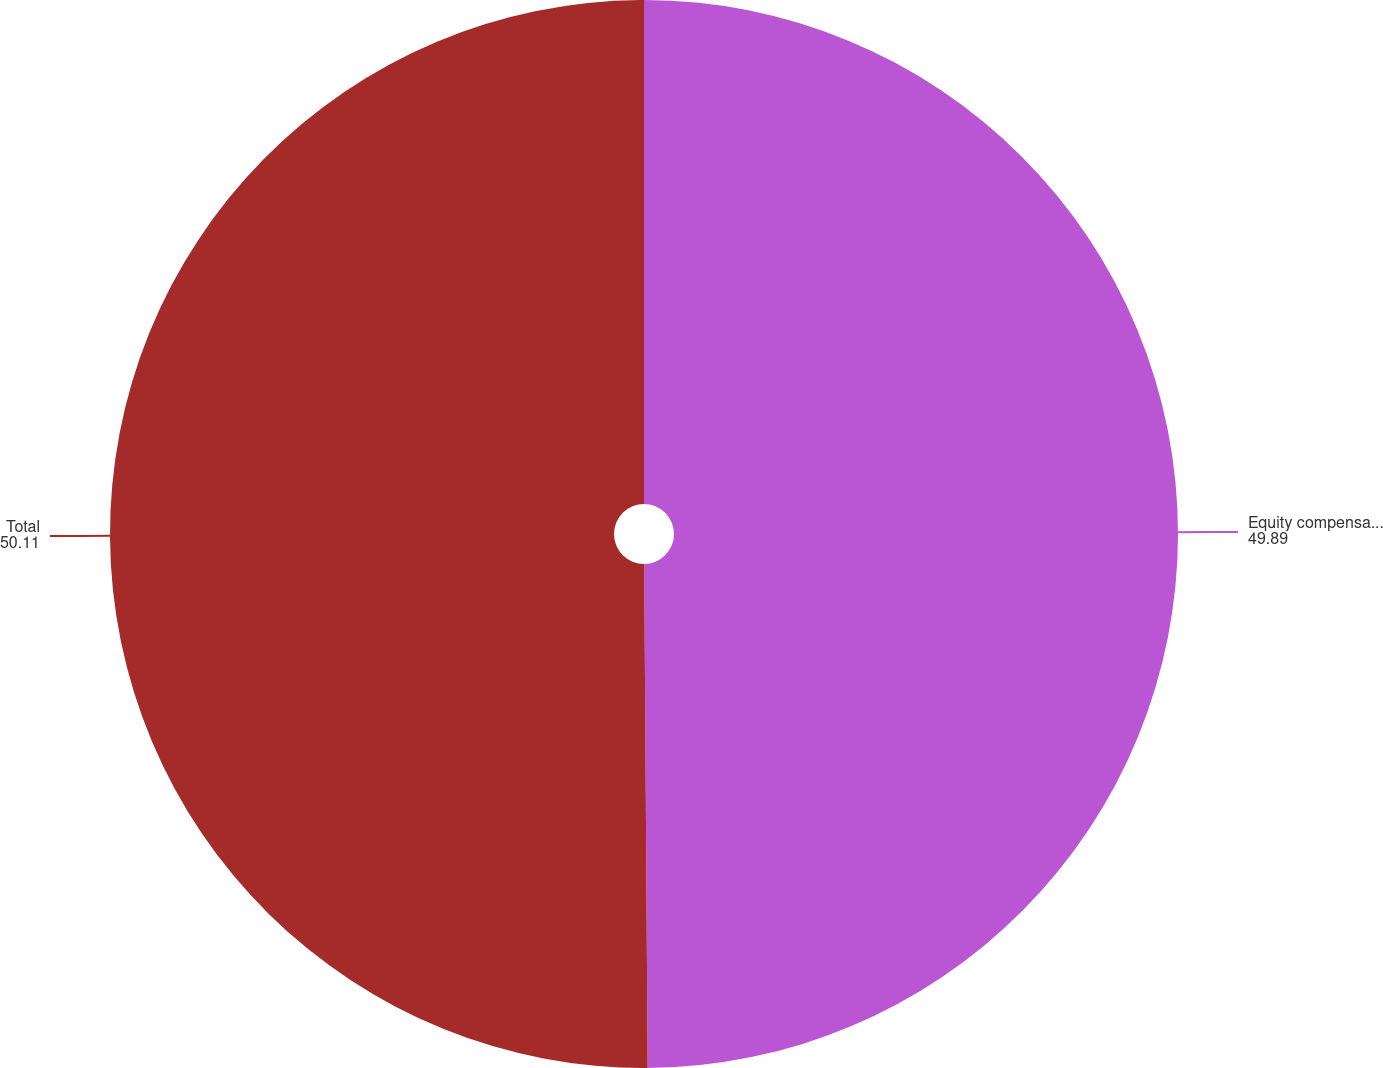Convert chart. <chart><loc_0><loc_0><loc_500><loc_500><pie_chart><fcel>Equity compensation plans<fcel>Total<nl><fcel>49.89%<fcel>50.11%<nl></chart> 